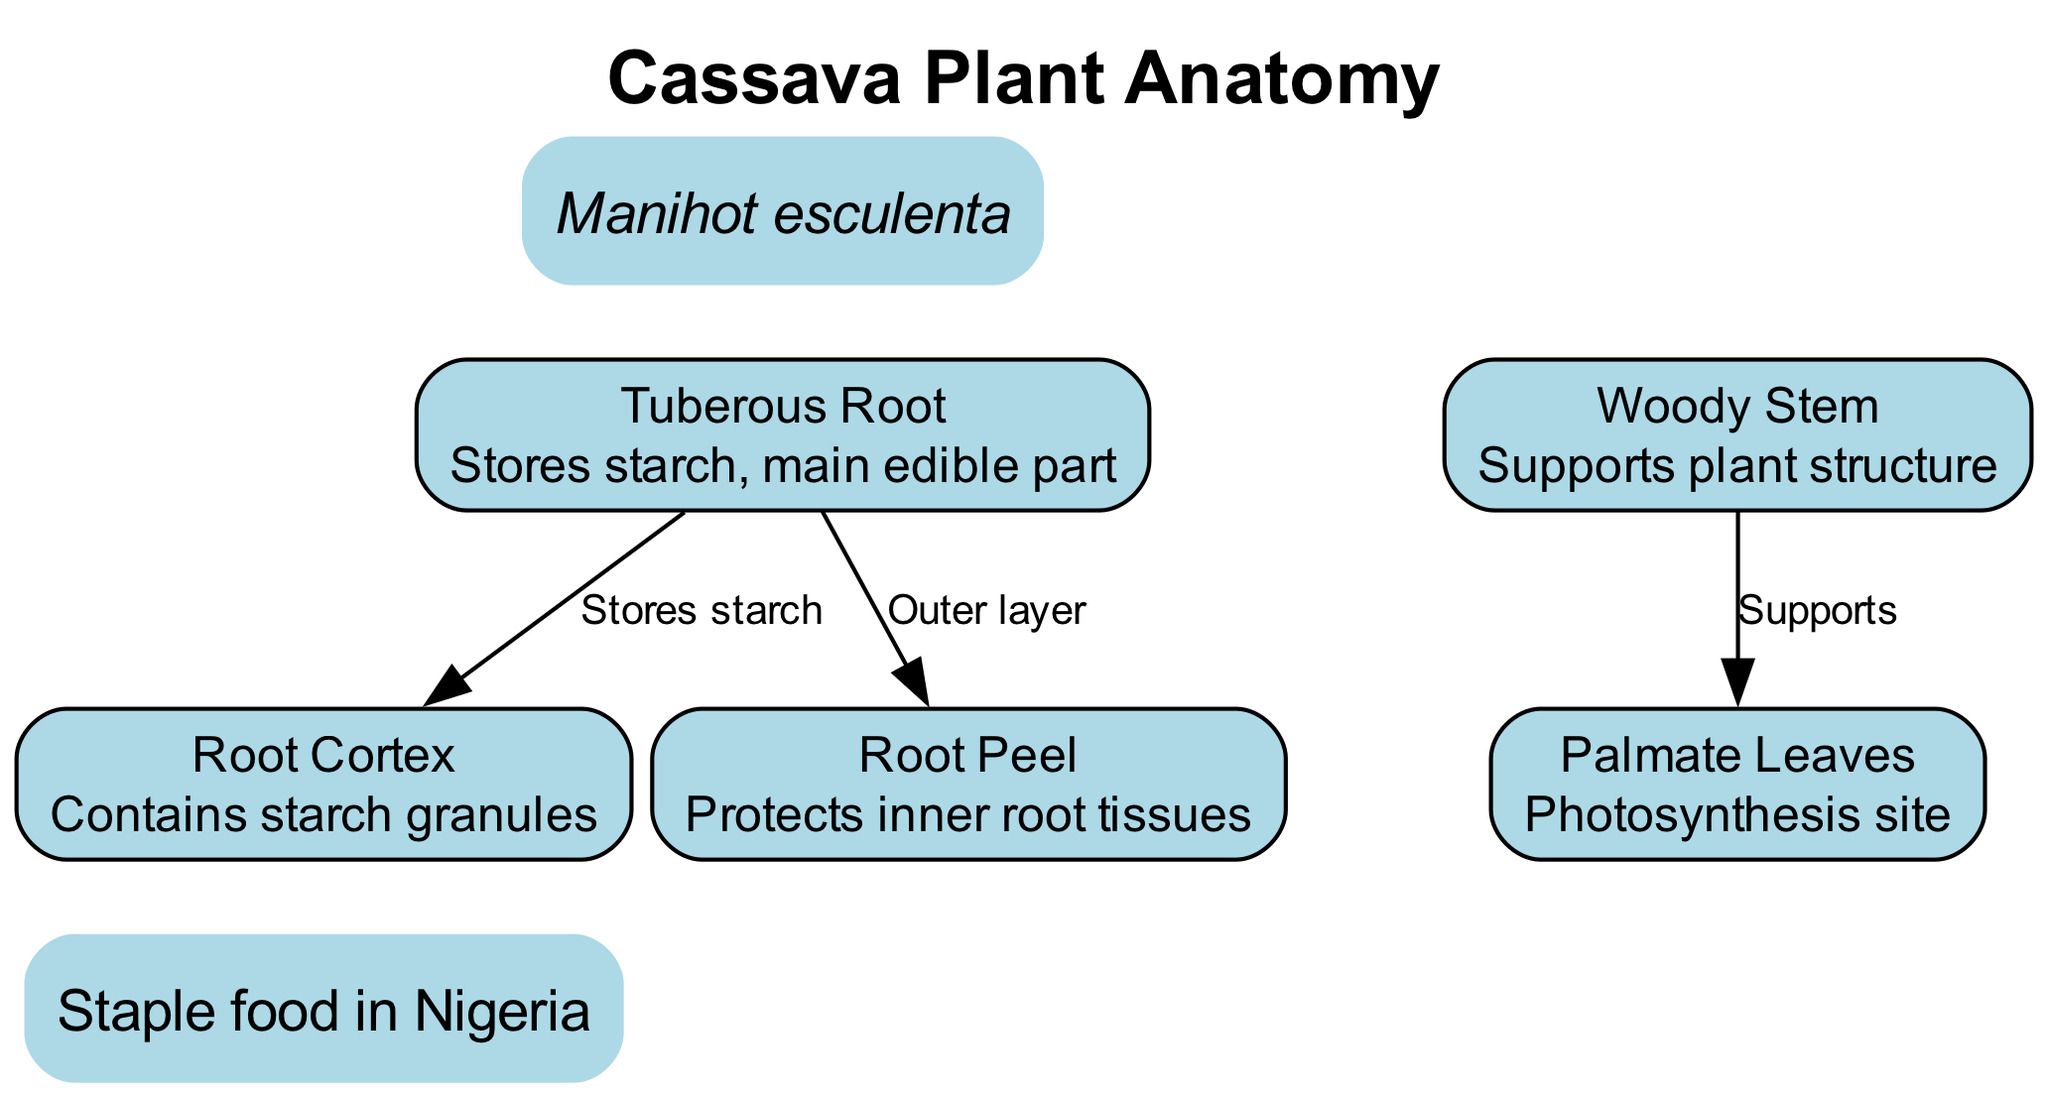What is the main edible part of the cassava plant? The diagram indicates that the tuberous root is the main edible part of the cassava plant and is responsible for storing starch.
Answer: Tuberous Root How many nodes are present in the diagram? The diagram contains a total of five nodes, which are the tuberous root, woody stem, palmate leaves, root cortex, and root peel.
Answer: Five What does the root cortex contain? According to the diagram, the root cortex contains starch granules, which are useful for starch storage in the cassava plant.
Answer: Starch granules What is the function of the woody stem? The diagram states that the woody stem supports the plant structure, indicating its role in maintaining the plant’s position and growth.
Answer: Supports plant structure What is the relationship between the tuberous root and the root cortex? The diagram illustrates that the tuberous root stores starch, and there is a direct connection to the root cortex, which contains starch granules. This indicates that starch storage occurs in both parts.
Answer: Stores starch Which part of the cassava plant is involved in photosynthesis? The diagram specifies that the palmate leaves are the site of photosynthesis, highlighting their role in converting sunlight into energy for the plant.
Answer: Palmate Leaves What outer layer protects the inner root tissues? The diagram shows that the root peel serves as the protective outer layer of the root, shielding the inner root tissues from damage and disease.
Answer: Root Peel What is the scientific name of cassava? The annotation at the top of the diagram states that the scientific name of cassava is Manihot esculenta, which is a vital piece of information for classification.
Answer: Manihot esculenta How does the stem relate to the leaves? The diagram indicates that the stem supports the leaves, illustrating a structural relationship where the stem holds the leaves up for optimal sunlight exposure.
Answer: Supports 